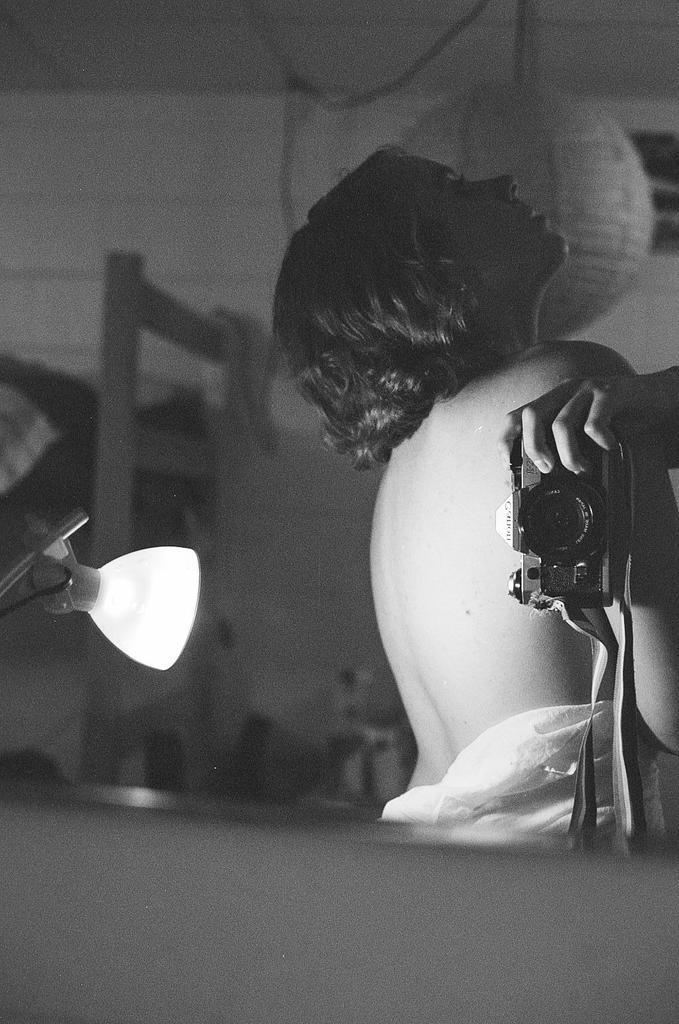Who is present in the image? There is a woman in the image. What object can be seen on the right side of the image? There is a camera on the right side of the image. What object can be seen on the left side of the image? There is a lamp on the left side of the image. What is visible in the background of the image? There is a wall in the background of the image. What type of education is the woman receiving in the image? There is no indication in the image that the woman is receiving any education. 